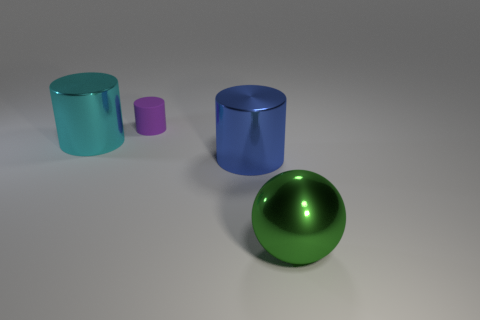Are there any other things that have the same material as the tiny object?
Ensure brevity in your answer.  No. What number of other objects are there of the same shape as the cyan shiny object?
Provide a succinct answer. 2. What color is the shiny sphere that is the same size as the blue cylinder?
Keep it short and to the point. Green. How many blocks are either large blue objects or cyan metallic objects?
Your response must be concise. 0. How many purple objects are there?
Keep it short and to the point. 1. There is a purple thing; is it the same shape as the metallic thing on the left side of the tiny purple rubber cylinder?
Offer a very short reply. Yes. How many objects are large cyan metallic cylinders or small objects?
Give a very brief answer. 2. What is the shape of the thing that is behind the big cylinder behind the blue metal thing?
Keep it short and to the point. Cylinder. Do the thing that is to the left of the tiny purple cylinder and the big green thing have the same shape?
Keep it short and to the point. No. There is a green sphere that is made of the same material as the big blue cylinder; what is its size?
Give a very brief answer. Large. 